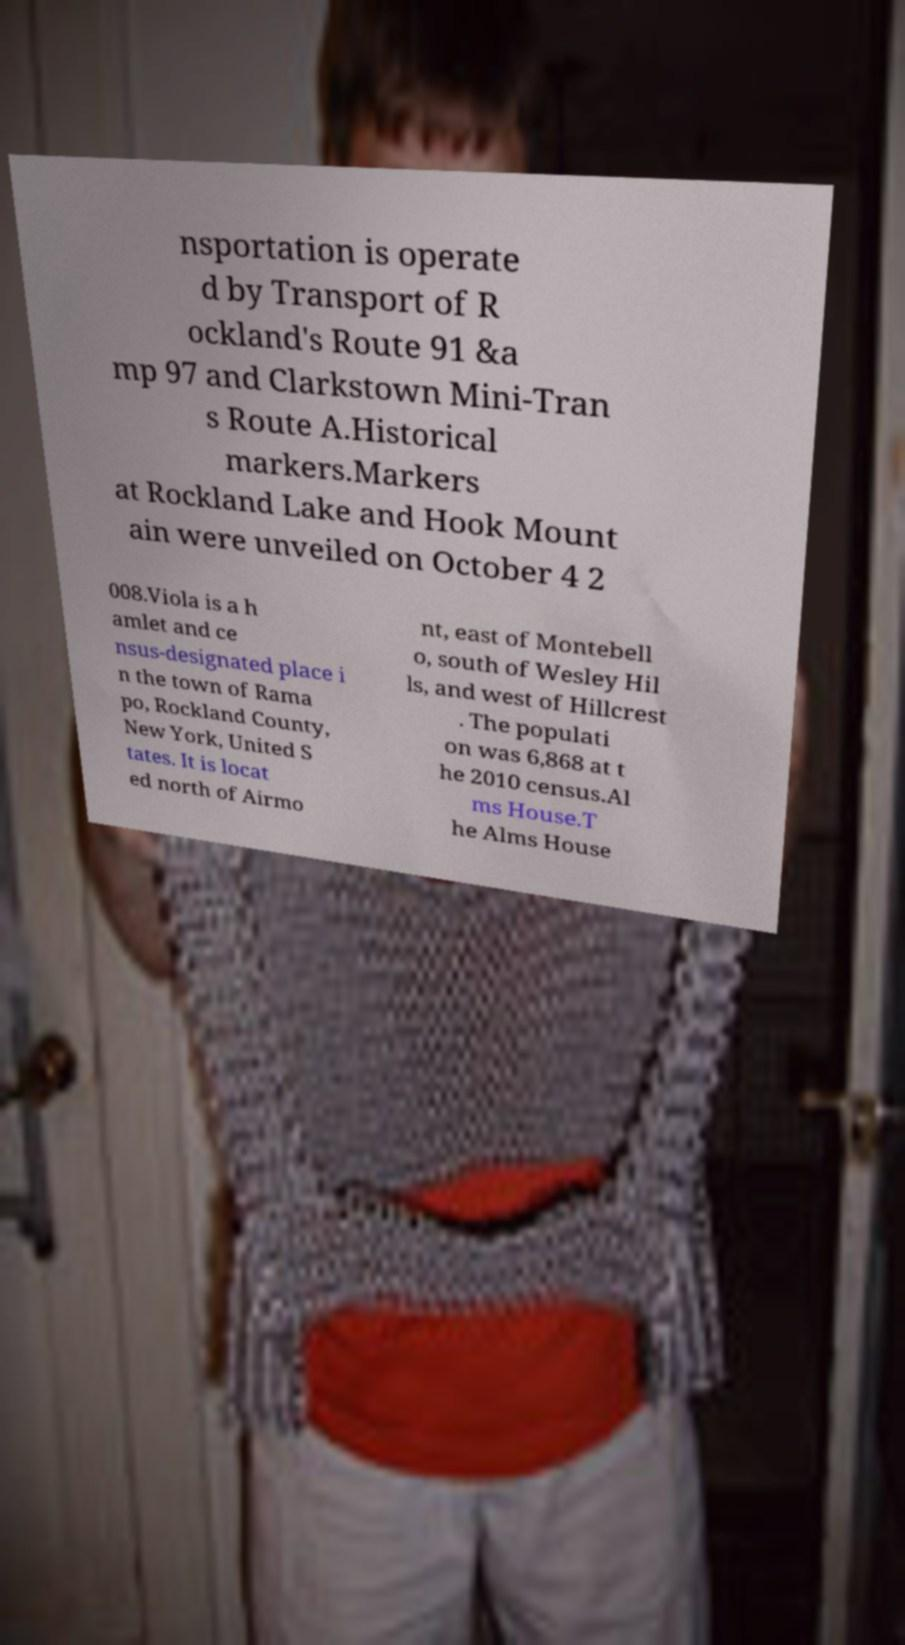Could you extract and type out the text from this image? nsportation is operate d by Transport of R ockland's Route 91 &a mp 97 and Clarkstown Mini-Tran s Route A.Historical markers.Markers at Rockland Lake and Hook Mount ain were unveiled on October 4 2 008.Viola is a h amlet and ce nsus-designated place i n the town of Rama po, Rockland County, New York, United S tates. It is locat ed north of Airmo nt, east of Montebell o, south of Wesley Hil ls, and west of Hillcrest . The populati on was 6,868 at t he 2010 census.Al ms House.T he Alms House 